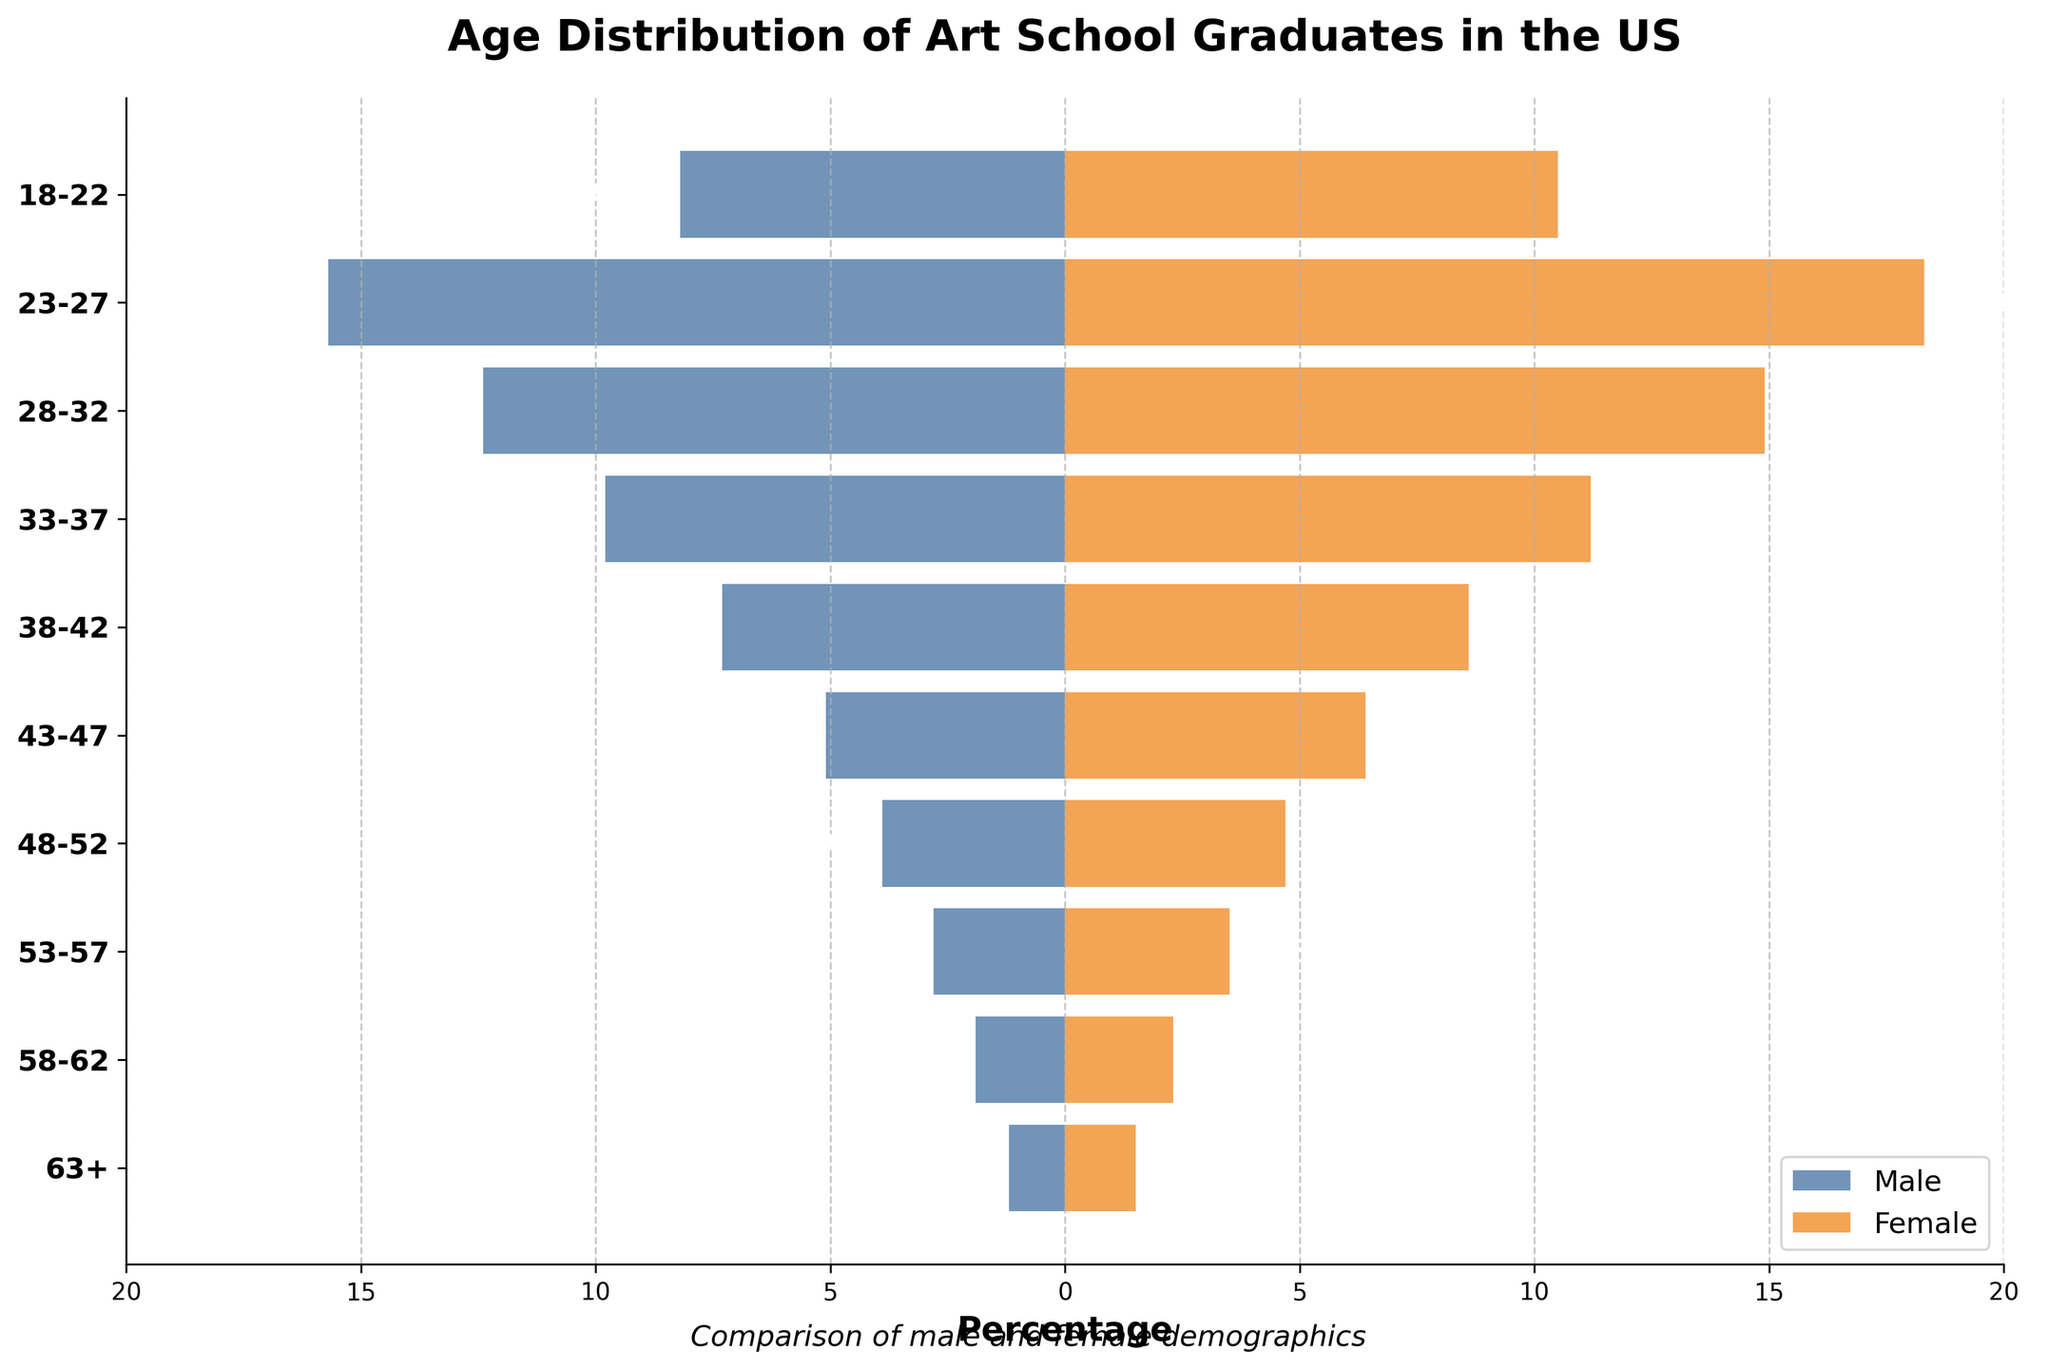What is the title of the figure? The title of the figure is prominently displayed at the top, indicating the overall subject of the visualized data.
Answer: Age Distribution of Art School Graduates in the US Which age group has the highest percentage of female graduates? By comparing the length of the bars for females across all age groups, the longest bar will correspond to the highest percentage.
Answer: 23-27 What is the percentage of male art school graduates in the 33-37 age group? Locate the 33-37 age group on the y-axis and observe the extent of the male bar (on the left side of the plot) to find the percentage.
Answer: 9.8% For which age range is the difference between male and female graduates the largest? For each age group, calculate the difference between the female and male percentages, and identify the group with the maximum difference.
Answer: 23-27 What are the overall trends in graduation percentages as age increases for both genders? Observe the bars' length from bottom to top (youngest to oldest age groups) for both males and females to infer any increasing, decreasing, or stable trends.
Answer: Both decline as age increases Compare the percentage of male graduates in the 18-22 age group with those in the 28-32 age group. Which is higher? Locate both age groups' bars on the male side and directly compare their lengths. The longer bar indicates the higher percentage.
Answer: 23-27 Which age group shows the least difference in graduation percentages between males and females? For each age group, calculate the absolute difference between female and male percentages, and find the group with the smallest difference.
Answer: 63+ What percentage of female art school graduates are aged 58-62? Locate the 58-62 age group on the y-axis and check the extent of the female bar (on the right side of the plot) to find the percentage.
Answer: 2.3% Is the percentage of female graduates in the 43-47 age group greater than that of male graduates in the 48-52 age group? Compare the height of the female bar for 43-47 on the right side with the male bar for 48-52 on the left side.
Answer: Yes How does the percentage of male graduates aged 63+ compare to that of female graduates in the same age group? Look at the bars for the 63+ age group for both genders and compare their lengths to see if one is higher than the other.
Answer: Females are higher 